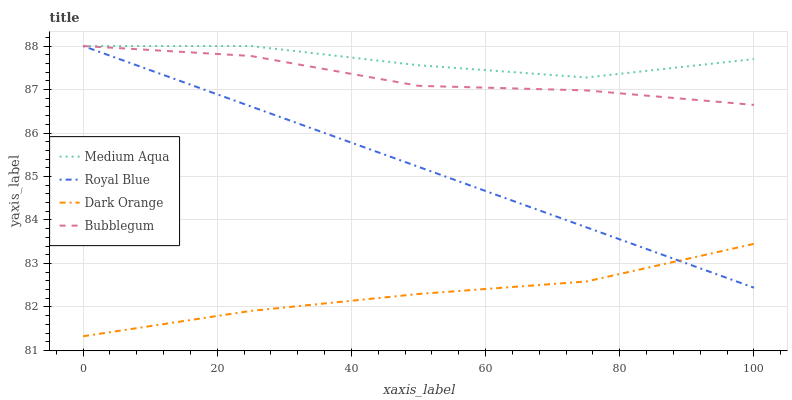Does Dark Orange have the minimum area under the curve?
Answer yes or no. Yes. Does Medium Aqua have the maximum area under the curve?
Answer yes or no. Yes. Does Bubblegum have the minimum area under the curve?
Answer yes or no. No. Does Bubblegum have the maximum area under the curve?
Answer yes or no. No. Is Royal Blue the smoothest?
Answer yes or no. Yes. Is Medium Aqua the roughest?
Answer yes or no. Yes. Is Bubblegum the smoothest?
Answer yes or no. No. Is Bubblegum the roughest?
Answer yes or no. No. Does Bubblegum have the lowest value?
Answer yes or no. No. Does Bubblegum have the highest value?
Answer yes or no. Yes. Does Dark Orange have the highest value?
Answer yes or no. No. Is Dark Orange less than Medium Aqua?
Answer yes or no. Yes. Is Bubblegum greater than Dark Orange?
Answer yes or no. Yes. Does Bubblegum intersect Royal Blue?
Answer yes or no. Yes. Is Bubblegum less than Royal Blue?
Answer yes or no. No. Is Bubblegum greater than Royal Blue?
Answer yes or no. No. Does Dark Orange intersect Medium Aqua?
Answer yes or no. No. 